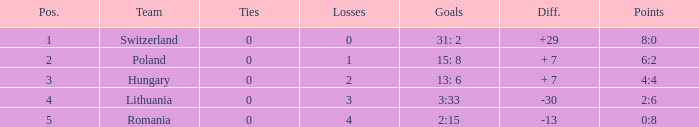Which team had fewer than 2 losses and a position number more than 1? Poland. 